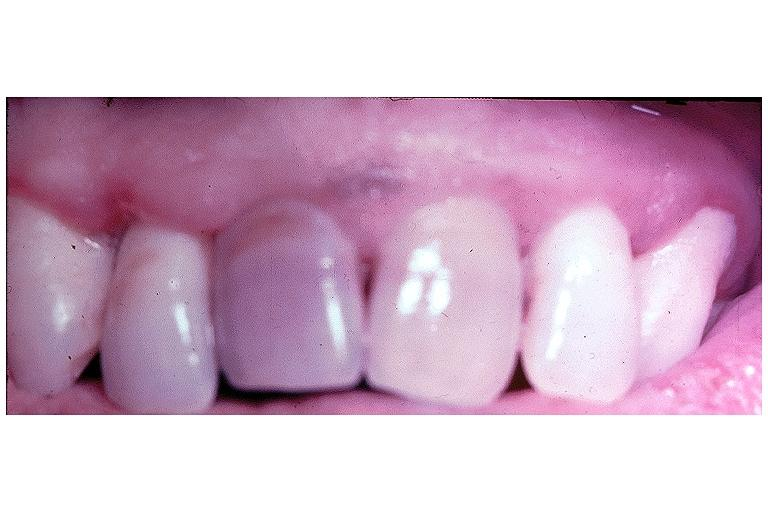does optic nerve show pulpal necrosis?
Answer the question using a single word or phrase. No 